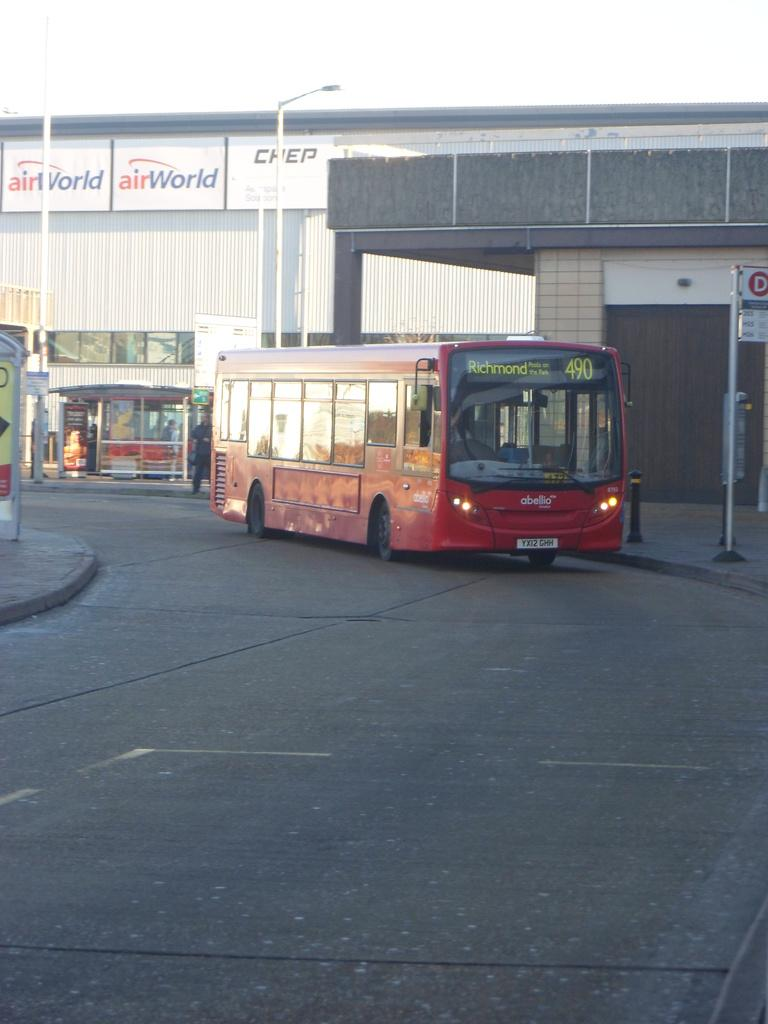What is on the road in the image? There is a vehicle on the road in the image. What can be seen in the background of the image? There are buildings visible in the image. What type of establishments can be seen in the image? There are shops visible in the image. What are the boards used for in the image? The boards might be used for advertising or displaying information in the image. Where is the nest of the metal birds located in the image? There is no nest or metal birds present in the image. 